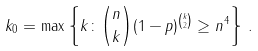Convert formula to latex. <formula><loc_0><loc_0><loc_500><loc_500>k _ { 0 } = \max \left \{ k \colon { n \choose k } ( 1 - p ) ^ { k \choose 2 } \geq n ^ { 4 } \right \} \, .</formula> 